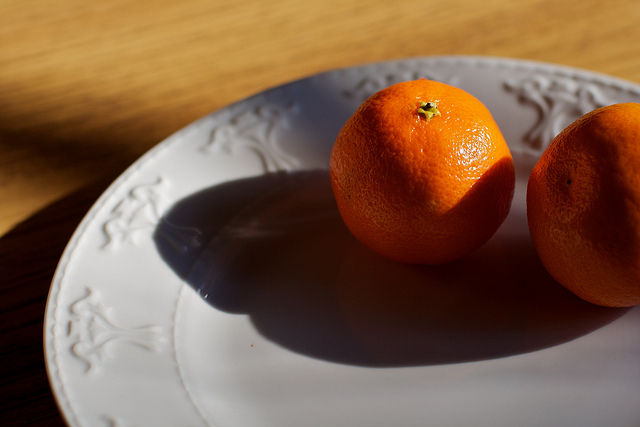Explain the visual content of the image in great detail. The image depicts two ripe and vibrant oranges positioned on an intricately designed plate. The plate has a subtle embossed pattern around its edge, resembling floral or vine decorations. The first orange is located towards the center-left of the plate, casting a soft shadow on the plate's surface under warm lighting. The second orange is near the right edge, partially cropped out of the frame, and shows detailed textures of its peel. The plate itself occupies a significant portion of the image, highlighting its detailed design against a wooden-textured background that brings a rustic and natural ambiance to the scene. 